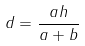<formula> <loc_0><loc_0><loc_500><loc_500>d = \frac { a h } { a + b }</formula> 